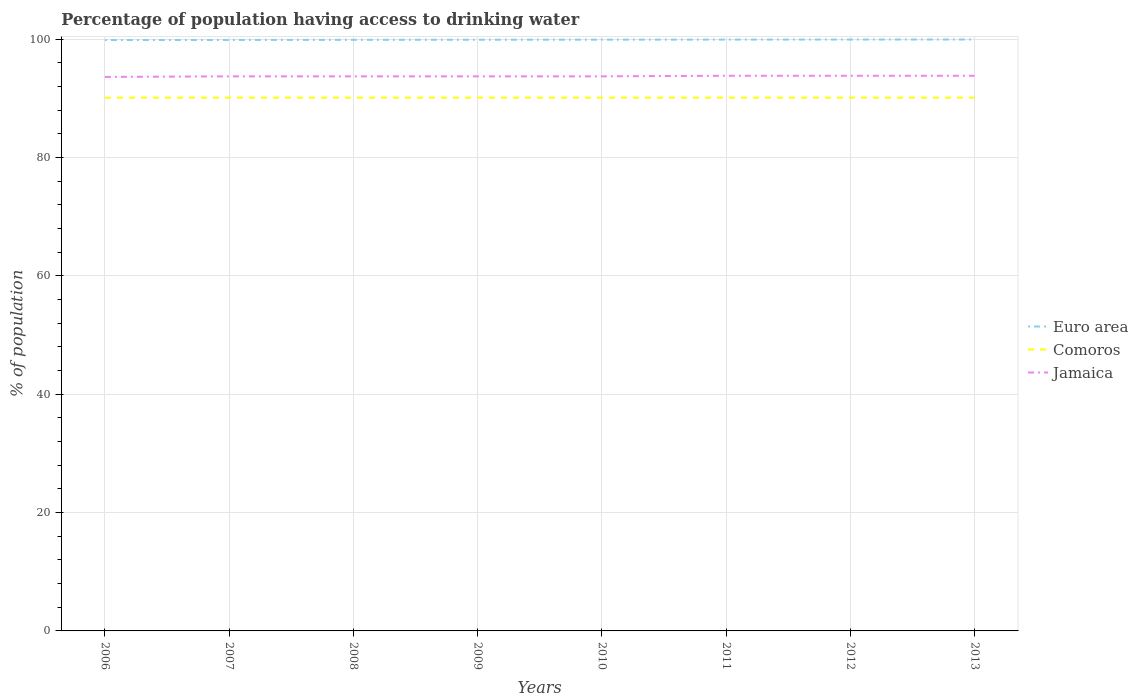Does the line corresponding to Comoros intersect with the line corresponding to Euro area?
Ensure brevity in your answer.  No. Is the number of lines equal to the number of legend labels?
Give a very brief answer. Yes. Across all years, what is the maximum percentage of population having access to drinking water in Jamaica?
Keep it short and to the point. 93.6. In which year was the percentage of population having access to drinking water in Jamaica maximum?
Keep it short and to the point. 2006. What is the total percentage of population having access to drinking water in Comoros in the graph?
Make the answer very short. 0. Is the percentage of population having access to drinking water in Jamaica strictly greater than the percentage of population having access to drinking water in Euro area over the years?
Your answer should be very brief. Yes. How many years are there in the graph?
Your response must be concise. 8. What is the difference between two consecutive major ticks on the Y-axis?
Provide a short and direct response. 20. How many legend labels are there?
Your response must be concise. 3. How are the legend labels stacked?
Offer a very short reply. Vertical. What is the title of the graph?
Provide a short and direct response. Percentage of population having access to drinking water. What is the label or title of the Y-axis?
Offer a terse response. % of population. What is the % of population of Euro area in 2006?
Your answer should be very brief. 99.83. What is the % of population in Comoros in 2006?
Provide a succinct answer. 90.1. What is the % of population in Jamaica in 2006?
Keep it short and to the point. 93.6. What is the % of population of Euro area in 2007?
Ensure brevity in your answer.  99.85. What is the % of population in Comoros in 2007?
Your answer should be compact. 90.1. What is the % of population in Jamaica in 2007?
Your answer should be compact. 93.7. What is the % of population of Euro area in 2008?
Provide a succinct answer. 99.87. What is the % of population of Comoros in 2008?
Your answer should be compact. 90.1. What is the % of population in Jamaica in 2008?
Offer a terse response. 93.7. What is the % of population of Euro area in 2009?
Keep it short and to the point. 99.88. What is the % of population in Comoros in 2009?
Provide a short and direct response. 90.1. What is the % of population of Jamaica in 2009?
Your answer should be very brief. 93.7. What is the % of population in Euro area in 2010?
Give a very brief answer. 99.89. What is the % of population of Comoros in 2010?
Ensure brevity in your answer.  90.1. What is the % of population of Jamaica in 2010?
Make the answer very short. 93.7. What is the % of population in Euro area in 2011?
Keep it short and to the point. 99.91. What is the % of population of Comoros in 2011?
Your answer should be very brief. 90.1. What is the % of population of Jamaica in 2011?
Your response must be concise. 93.8. What is the % of population of Euro area in 2012?
Give a very brief answer. 99.92. What is the % of population in Comoros in 2012?
Your answer should be compact. 90.1. What is the % of population of Jamaica in 2012?
Provide a succinct answer. 93.8. What is the % of population in Euro area in 2013?
Provide a short and direct response. 99.93. What is the % of population in Comoros in 2013?
Make the answer very short. 90.1. What is the % of population in Jamaica in 2013?
Keep it short and to the point. 93.8. Across all years, what is the maximum % of population of Euro area?
Your answer should be very brief. 99.93. Across all years, what is the maximum % of population of Comoros?
Provide a short and direct response. 90.1. Across all years, what is the maximum % of population of Jamaica?
Your response must be concise. 93.8. Across all years, what is the minimum % of population in Euro area?
Your answer should be compact. 99.83. Across all years, what is the minimum % of population of Comoros?
Your answer should be very brief. 90.1. Across all years, what is the minimum % of population in Jamaica?
Make the answer very short. 93.6. What is the total % of population of Euro area in the graph?
Ensure brevity in your answer.  799.08. What is the total % of population of Comoros in the graph?
Provide a short and direct response. 720.8. What is the total % of population of Jamaica in the graph?
Keep it short and to the point. 749.8. What is the difference between the % of population of Euro area in 2006 and that in 2007?
Make the answer very short. -0.01. What is the difference between the % of population of Comoros in 2006 and that in 2007?
Provide a succinct answer. 0. What is the difference between the % of population of Euro area in 2006 and that in 2008?
Offer a terse response. -0.03. What is the difference between the % of population in Euro area in 2006 and that in 2009?
Keep it short and to the point. -0.05. What is the difference between the % of population in Comoros in 2006 and that in 2009?
Offer a very short reply. 0. What is the difference between the % of population in Euro area in 2006 and that in 2010?
Keep it short and to the point. -0.06. What is the difference between the % of population in Comoros in 2006 and that in 2010?
Make the answer very short. 0. What is the difference between the % of population in Jamaica in 2006 and that in 2010?
Give a very brief answer. -0.1. What is the difference between the % of population of Euro area in 2006 and that in 2011?
Make the answer very short. -0.07. What is the difference between the % of population of Comoros in 2006 and that in 2011?
Your answer should be very brief. 0. What is the difference between the % of population of Euro area in 2006 and that in 2012?
Offer a very short reply. -0.08. What is the difference between the % of population of Comoros in 2006 and that in 2012?
Your answer should be very brief. 0. What is the difference between the % of population of Jamaica in 2006 and that in 2012?
Your answer should be very brief. -0.2. What is the difference between the % of population of Euro area in 2006 and that in 2013?
Your answer should be very brief. -0.09. What is the difference between the % of population in Comoros in 2006 and that in 2013?
Give a very brief answer. 0. What is the difference between the % of population in Jamaica in 2006 and that in 2013?
Keep it short and to the point. -0.2. What is the difference between the % of population in Euro area in 2007 and that in 2008?
Your answer should be very brief. -0.02. What is the difference between the % of population of Comoros in 2007 and that in 2008?
Provide a short and direct response. 0. What is the difference between the % of population in Jamaica in 2007 and that in 2008?
Your response must be concise. 0. What is the difference between the % of population of Euro area in 2007 and that in 2009?
Your answer should be very brief. -0.03. What is the difference between the % of population of Jamaica in 2007 and that in 2009?
Ensure brevity in your answer.  0. What is the difference between the % of population of Euro area in 2007 and that in 2010?
Give a very brief answer. -0.05. What is the difference between the % of population in Jamaica in 2007 and that in 2010?
Offer a terse response. 0. What is the difference between the % of population of Euro area in 2007 and that in 2011?
Your response must be concise. -0.06. What is the difference between the % of population in Jamaica in 2007 and that in 2011?
Keep it short and to the point. -0.1. What is the difference between the % of population of Euro area in 2007 and that in 2012?
Your answer should be compact. -0.07. What is the difference between the % of population in Comoros in 2007 and that in 2012?
Provide a short and direct response. 0. What is the difference between the % of population in Jamaica in 2007 and that in 2012?
Offer a very short reply. -0.1. What is the difference between the % of population in Euro area in 2007 and that in 2013?
Your answer should be compact. -0.08. What is the difference between the % of population of Euro area in 2008 and that in 2009?
Keep it short and to the point. -0.02. What is the difference between the % of population in Euro area in 2008 and that in 2010?
Offer a very short reply. -0.03. What is the difference between the % of population of Euro area in 2008 and that in 2011?
Your answer should be very brief. -0.04. What is the difference between the % of population in Euro area in 2008 and that in 2012?
Your answer should be compact. -0.05. What is the difference between the % of population of Jamaica in 2008 and that in 2012?
Offer a very short reply. -0.1. What is the difference between the % of population of Euro area in 2008 and that in 2013?
Your answer should be very brief. -0.06. What is the difference between the % of population in Jamaica in 2008 and that in 2013?
Provide a short and direct response. -0.1. What is the difference between the % of population in Euro area in 2009 and that in 2010?
Make the answer very short. -0.01. What is the difference between the % of population of Comoros in 2009 and that in 2010?
Make the answer very short. 0. What is the difference between the % of population of Jamaica in 2009 and that in 2010?
Your answer should be very brief. 0. What is the difference between the % of population of Euro area in 2009 and that in 2011?
Your answer should be very brief. -0.03. What is the difference between the % of population of Euro area in 2009 and that in 2012?
Offer a very short reply. -0.04. What is the difference between the % of population in Comoros in 2009 and that in 2012?
Offer a very short reply. 0. What is the difference between the % of population in Jamaica in 2009 and that in 2012?
Offer a terse response. -0.1. What is the difference between the % of population in Euro area in 2009 and that in 2013?
Your response must be concise. -0.05. What is the difference between the % of population in Comoros in 2009 and that in 2013?
Give a very brief answer. 0. What is the difference between the % of population in Euro area in 2010 and that in 2011?
Provide a succinct answer. -0.01. What is the difference between the % of population of Comoros in 2010 and that in 2011?
Your answer should be compact. 0. What is the difference between the % of population in Euro area in 2010 and that in 2012?
Your answer should be compact. -0.02. What is the difference between the % of population in Comoros in 2010 and that in 2012?
Your answer should be compact. 0. What is the difference between the % of population of Jamaica in 2010 and that in 2012?
Provide a succinct answer. -0.1. What is the difference between the % of population in Euro area in 2010 and that in 2013?
Your answer should be compact. -0.03. What is the difference between the % of population of Comoros in 2010 and that in 2013?
Give a very brief answer. 0. What is the difference between the % of population in Euro area in 2011 and that in 2012?
Provide a succinct answer. -0.01. What is the difference between the % of population of Comoros in 2011 and that in 2012?
Keep it short and to the point. 0. What is the difference between the % of population of Euro area in 2011 and that in 2013?
Offer a very short reply. -0.02. What is the difference between the % of population of Euro area in 2012 and that in 2013?
Make the answer very short. -0.01. What is the difference between the % of population in Comoros in 2012 and that in 2013?
Provide a succinct answer. 0. What is the difference between the % of population in Jamaica in 2012 and that in 2013?
Offer a terse response. 0. What is the difference between the % of population in Euro area in 2006 and the % of population in Comoros in 2007?
Your answer should be compact. 9.73. What is the difference between the % of population in Euro area in 2006 and the % of population in Jamaica in 2007?
Give a very brief answer. 6.13. What is the difference between the % of population in Comoros in 2006 and the % of population in Jamaica in 2007?
Your response must be concise. -3.6. What is the difference between the % of population of Euro area in 2006 and the % of population of Comoros in 2008?
Offer a very short reply. 9.73. What is the difference between the % of population of Euro area in 2006 and the % of population of Jamaica in 2008?
Provide a short and direct response. 6.13. What is the difference between the % of population in Euro area in 2006 and the % of population in Comoros in 2009?
Your answer should be compact. 9.73. What is the difference between the % of population of Euro area in 2006 and the % of population of Jamaica in 2009?
Ensure brevity in your answer.  6.13. What is the difference between the % of population in Euro area in 2006 and the % of population in Comoros in 2010?
Offer a very short reply. 9.73. What is the difference between the % of population in Euro area in 2006 and the % of population in Jamaica in 2010?
Give a very brief answer. 6.13. What is the difference between the % of population of Euro area in 2006 and the % of population of Comoros in 2011?
Offer a very short reply. 9.73. What is the difference between the % of population in Euro area in 2006 and the % of population in Jamaica in 2011?
Your answer should be compact. 6.03. What is the difference between the % of population of Euro area in 2006 and the % of population of Comoros in 2012?
Offer a terse response. 9.73. What is the difference between the % of population in Euro area in 2006 and the % of population in Jamaica in 2012?
Offer a very short reply. 6.03. What is the difference between the % of population in Comoros in 2006 and the % of population in Jamaica in 2012?
Make the answer very short. -3.7. What is the difference between the % of population in Euro area in 2006 and the % of population in Comoros in 2013?
Keep it short and to the point. 9.73. What is the difference between the % of population of Euro area in 2006 and the % of population of Jamaica in 2013?
Offer a very short reply. 6.03. What is the difference between the % of population of Comoros in 2006 and the % of population of Jamaica in 2013?
Your answer should be very brief. -3.7. What is the difference between the % of population in Euro area in 2007 and the % of population in Comoros in 2008?
Your answer should be compact. 9.75. What is the difference between the % of population of Euro area in 2007 and the % of population of Jamaica in 2008?
Keep it short and to the point. 6.15. What is the difference between the % of population in Comoros in 2007 and the % of population in Jamaica in 2008?
Provide a succinct answer. -3.6. What is the difference between the % of population in Euro area in 2007 and the % of population in Comoros in 2009?
Make the answer very short. 9.75. What is the difference between the % of population of Euro area in 2007 and the % of population of Jamaica in 2009?
Make the answer very short. 6.15. What is the difference between the % of population of Euro area in 2007 and the % of population of Comoros in 2010?
Give a very brief answer. 9.75. What is the difference between the % of population in Euro area in 2007 and the % of population in Jamaica in 2010?
Give a very brief answer. 6.15. What is the difference between the % of population in Comoros in 2007 and the % of population in Jamaica in 2010?
Keep it short and to the point. -3.6. What is the difference between the % of population in Euro area in 2007 and the % of population in Comoros in 2011?
Ensure brevity in your answer.  9.75. What is the difference between the % of population of Euro area in 2007 and the % of population of Jamaica in 2011?
Keep it short and to the point. 6.05. What is the difference between the % of population in Comoros in 2007 and the % of population in Jamaica in 2011?
Give a very brief answer. -3.7. What is the difference between the % of population of Euro area in 2007 and the % of population of Comoros in 2012?
Offer a very short reply. 9.75. What is the difference between the % of population of Euro area in 2007 and the % of population of Jamaica in 2012?
Offer a very short reply. 6.05. What is the difference between the % of population in Euro area in 2007 and the % of population in Comoros in 2013?
Your answer should be very brief. 9.75. What is the difference between the % of population of Euro area in 2007 and the % of population of Jamaica in 2013?
Your answer should be very brief. 6.05. What is the difference between the % of population of Comoros in 2007 and the % of population of Jamaica in 2013?
Offer a terse response. -3.7. What is the difference between the % of population of Euro area in 2008 and the % of population of Comoros in 2009?
Give a very brief answer. 9.77. What is the difference between the % of population of Euro area in 2008 and the % of population of Jamaica in 2009?
Give a very brief answer. 6.17. What is the difference between the % of population in Comoros in 2008 and the % of population in Jamaica in 2009?
Provide a succinct answer. -3.6. What is the difference between the % of population of Euro area in 2008 and the % of population of Comoros in 2010?
Your response must be concise. 9.77. What is the difference between the % of population of Euro area in 2008 and the % of population of Jamaica in 2010?
Keep it short and to the point. 6.17. What is the difference between the % of population of Comoros in 2008 and the % of population of Jamaica in 2010?
Make the answer very short. -3.6. What is the difference between the % of population of Euro area in 2008 and the % of population of Comoros in 2011?
Make the answer very short. 9.77. What is the difference between the % of population in Euro area in 2008 and the % of population in Jamaica in 2011?
Keep it short and to the point. 6.07. What is the difference between the % of population of Comoros in 2008 and the % of population of Jamaica in 2011?
Offer a very short reply. -3.7. What is the difference between the % of population in Euro area in 2008 and the % of population in Comoros in 2012?
Provide a succinct answer. 9.77. What is the difference between the % of population of Euro area in 2008 and the % of population of Jamaica in 2012?
Your answer should be compact. 6.07. What is the difference between the % of population in Euro area in 2008 and the % of population in Comoros in 2013?
Provide a short and direct response. 9.77. What is the difference between the % of population in Euro area in 2008 and the % of population in Jamaica in 2013?
Give a very brief answer. 6.07. What is the difference between the % of population in Euro area in 2009 and the % of population in Comoros in 2010?
Keep it short and to the point. 9.78. What is the difference between the % of population of Euro area in 2009 and the % of population of Jamaica in 2010?
Give a very brief answer. 6.18. What is the difference between the % of population of Comoros in 2009 and the % of population of Jamaica in 2010?
Your response must be concise. -3.6. What is the difference between the % of population in Euro area in 2009 and the % of population in Comoros in 2011?
Provide a succinct answer. 9.78. What is the difference between the % of population in Euro area in 2009 and the % of population in Jamaica in 2011?
Offer a terse response. 6.08. What is the difference between the % of population of Euro area in 2009 and the % of population of Comoros in 2012?
Ensure brevity in your answer.  9.78. What is the difference between the % of population in Euro area in 2009 and the % of population in Jamaica in 2012?
Keep it short and to the point. 6.08. What is the difference between the % of population in Comoros in 2009 and the % of population in Jamaica in 2012?
Offer a terse response. -3.7. What is the difference between the % of population of Euro area in 2009 and the % of population of Comoros in 2013?
Provide a succinct answer. 9.78. What is the difference between the % of population in Euro area in 2009 and the % of population in Jamaica in 2013?
Your response must be concise. 6.08. What is the difference between the % of population of Euro area in 2010 and the % of population of Comoros in 2011?
Keep it short and to the point. 9.79. What is the difference between the % of population in Euro area in 2010 and the % of population in Jamaica in 2011?
Give a very brief answer. 6.09. What is the difference between the % of population in Euro area in 2010 and the % of population in Comoros in 2012?
Offer a very short reply. 9.79. What is the difference between the % of population of Euro area in 2010 and the % of population of Jamaica in 2012?
Offer a terse response. 6.09. What is the difference between the % of population in Comoros in 2010 and the % of population in Jamaica in 2012?
Ensure brevity in your answer.  -3.7. What is the difference between the % of population of Euro area in 2010 and the % of population of Comoros in 2013?
Offer a terse response. 9.79. What is the difference between the % of population in Euro area in 2010 and the % of population in Jamaica in 2013?
Ensure brevity in your answer.  6.09. What is the difference between the % of population in Comoros in 2010 and the % of population in Jamaica in 2013?
Your answer should be very brief. -3.7. What is the difference between the % of population in Euro area in 2011 and the % of population in Comoros in 2012?
Make the answer very short. 9.81. What is the difference between the % of population in Euro area in 2011 and the % of population in Jamaica in 2012?
Make the answer very short. 6.11. What is the difference between the % of population of Comoros in 2011 and the % of population of Jamaica in 2012?
Give a very brief answer. -3.7. What is the difference between the % of population in Euro area in 2011 and the % of population in Comoros in 2013?
Ensure brevity in your answer.  9.81. What is the difference between the % of population in Euro area in 2011 and the % of population in Jamaica in 2013?
Provide a short and direct response. 6.11. What is the difference between the % of population of Euro area in 2012 and the % of population of Comoros in 2013?
Make the answer very short. 9.82. What is the difference between the % of population in Euro area in 2012 and the % of population in Jamaica in 2013?
Provide a succinct answer. 6.12. What is the average % of population of Euro area per year?
Your response must be concise. 99.88. What is the average % of population of Comoros per year?
Give a very brief answer. 90.1. What is the average % of population of Jamaica per year?
Ensure brevity in your answer.  93.72. In the year 2006, what is the difference between the % of population in Euro area and % of population in Comoros?
Your response must be concise. 9.73. In the year 2006, what is the difference between the % of population of Euro area and % of population of Jamaica?
Provide a succinct answer. 6.23. In the year 2007, what is the difference between the % of population of Euro area and % of population of Comoros?
Your answer should be compact. 9.75. In the year 2007, what is the difference between the % of population of Euro area and % of population of Jamaica?
Offer a very short reply. 6.15. In the year 2008, what is the difference between the % of population of Euro area and % of population of Comoros?
Offer a terse response. 9.77. In the year 2008, what is the difference between the % of population in Euro area and % of population in Jamaica?
Offer a terse response. 6.17. In the year 2009, what is the difference between the % of population of Euro area and % of population of Comoros?
Ensure brevity in your answer.  9.78. In the year 2009, what is the difference between the % of population in Euro area and % of population in Jamaica?
Provide a short and direct response. 6.18. In the year 2010, what is the difference between the % of population of Euro area and % of population of Comoros?
Provide a succinct answer. 9.79. In the year 2010, what is the difference between the % of population of Euro area and % of population of Jamaica?
Your answer should be compact. 6.19. In the year 2011, what is the difference between the % of population in Euro area and % of population in Comoros?
Provide a short and direct response. 9.81. In the year 2011, what is the difference between the % of population of Euro area and % of population of Jamaica?
Your response must be concise. 6.11. In the year 2012, what is the difference between the % of population of Euro area and % of population of Comoros?
Ensure brevity in your answer.  9.82. In the year 2012, what is the difference between the % of population of Euro area and % of population of Jamaica?
Offer a terse response. 6.12. In the year 2013, what is the difference between the % of population in Euro area and % of population in Comoros?
Make the answer very short. 9.83. In the year 2013, what is the difference between the % of population of Euro area and % of population of Jamaica?
Keep it short and to the point. 6.13. In the year 2013, what is the difference between the % of population of Comoros and % of population of Jamaica?
Give a very brief answer. -3.7. What is the ratio of the % of population in Euro area in 2006 to that in 2007?
Offer a very short reply. 1. What is the ratio of the % of population in Comoros in 2006 to that in 2007?
Your response must be concise. 1. What is the ratio of the % of population of Jamaica in 2006 to that in 2007?
Your answer should be very brief. 1. What is the ratio of the % of population in Comoros in 2006 to that in 2008?
Provide a short and direct response. 1. What is the ratio of the % of population of Jamaica in 2006 to that in 2008?
Ensure brevity in your answer.  1. What is the ratio of the % of population in Euro area in 2006 to that in 2009?
Provide a short and direct response. 1. What is the ratio of the % of population of Jamaica in 2006 to that in 2009?
Your answer should be compact. 1. What is the ratio of the % of population of Comoros in 2006 to that in 2010?
Offer a very short reply. 1. What is the ratio of the % of population of Euro area in 2006 to that in 2011?
Your response must be concise. 1. What is the ratio of the % of population in Euro area in 2006 to that in 2012?
Provide a short and direct response. 1. What is the ratio of the % of population in Jamaica in 2006 to that in 2012?
Offer a very short reply. 1. What is the ratio of the % of population in Euro area in 2007 to that in 2008?
Ensure brevity in your answer.  1. What is the ratio of the % of population in Comoros in 2007 to that in 2008?
Your answer should be very brief. 1. What is the ratio of the % of population in Euro area in 2007 to that in 2009?
Your response must be concise. 1. What is the ratio of the % of population of Jamaica in 2007 to that in 2009?
Offer a very short reply. 1. What is the ratio of the % of population of Euro area in 2007 to that in 2011?
Make the answer very short. 1. What is the ratio of the % of population of Comoros in 2007 to that in 2011?
Make the answer very short. 1. What is the ratio of the % of population in Comoros in 2007 to that in 2012?
Ensure brevity in your answer.  1. What is the ratio of the % of population of Euro area in 2007 to that in 2013?
Provide a succinct answer. 1. What is the ratio of the % of population of Jamaica in 2007 to that in 2013?
Your response must be concise. 1. What is the ratio of the % of population of Euro area in 2008 to that in 2009?
Provide a short and direct response. 1. What is the ratio of the % of population in Euro area in 2008 to that in 2010?
Make the answer very short. 1. What is the ratio of the % of population of Comoros in 2008 to that in 2010?
Ensure brevity in your answer.  1. What is the ratio of the % of population in Jamaica in 2008 to that in 2010?
Offer a terse response. 1. What is the ratio of the % of population in Euro area in 2008 to that in 2011?
Provide a short and direct response. 1. What is the ratio of the % of population of Comoros in 2008 to that in 2011?
Make the answer very short. 1. What is the ratio of the % of population in Jamaica in 2008 to that in 2011?
Give a very brief answer. 1. What is the ratio of the % of population in Jamaica in 2008 to that in 2012?
Give a very brief answer. 1. What is the ratio of the % of population in Comoros in 2008 to that in 2013?
Provide a succinct answer. 1. What is the ratio of the % of population in Jamaica in 2008 to that in 2013?
Offer a terse response. 1. What is the ratio of the % of population of Comoros in 2009 to that in 2010?
Your answer should be compact. 1. What is the ratio of the % of population of Jamaica in 2009 to that in 2010?
Ensure brevity in your answer.  1. What is the ratio of the % of population of Jamaica in 2009 to that in 2011?
Give a very brief answer. 1. What is the ratio of the % of population of Euro area in 2009 to that in 2012?
Provide a short and direct response. 1. What is the ratio of the % of population in Comoros in 2009 to that in 2012?
Your answer should be compact. 1. What is the ratio of the % of population in Euro area in 2009 to that in 2013?
Give a very brief answer. 1. What is the ratio of the % of population of Euro area in 2010 to that in 2011?
Provide a succinct answer. 1. What is the ratio of the % of population of Euro area in 2010 to that in 2012?
Give a very brief answer. 1. What is the ratio of the % of population in Comoros in 2010 to that in 2012?
Your answer should be compact. 1. What is the ratio of the % of population of Jamaica in 2010 to that in 2012?
Ensure brevity in your answer.  1. What is the ratio of the % of population of Jamaica in 2010 to that in 2013?
Your answer should be very brief. 1. What is the ratio of the % of population in Euro area in 2011 to that in 2012?
Ensure brevity in your answer.  1. What is the ratio of the % of population of Euro area in 2011 to that in 2013?
Provide a short and direct response. 1. What is the ratio of the % of population in Comoros in 2011 to that in 2013?
Offer a terse response. 1. What is the ratio of the % of population in Jamaica in 2011 to that in 2013?
Offer a very short reply. 1. What is the ratio of the % of population in Euro area in 2012 to that in 2013?
Your answer should be very brief. 1. What is the ratio of the % of population of Comoros in 2012 to that in 2013?
Your answer should be very brief. 1. What is the ratio of the % of population in Jamaica in 2012 to that in 2013?
Offer a terse response. 1. What is the difference between the highest and the second highest % of population of Euro area?
Offer a terse response. 0.01. What is the difference between the highest and the second highest % of population of Jamaica?
Keep it short and to the point. 0. What is the difference between the highest and the lowest % of population of Euro area?
Provide a succinct answer. 0.09. 